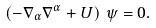<formula> <loc_0><loc_0><loc_500><loc_500>\left ( - \nabla _ { \alpha } \nabla ^ { \alpha } + U \right ) \, \psi = 0 .</formula> 